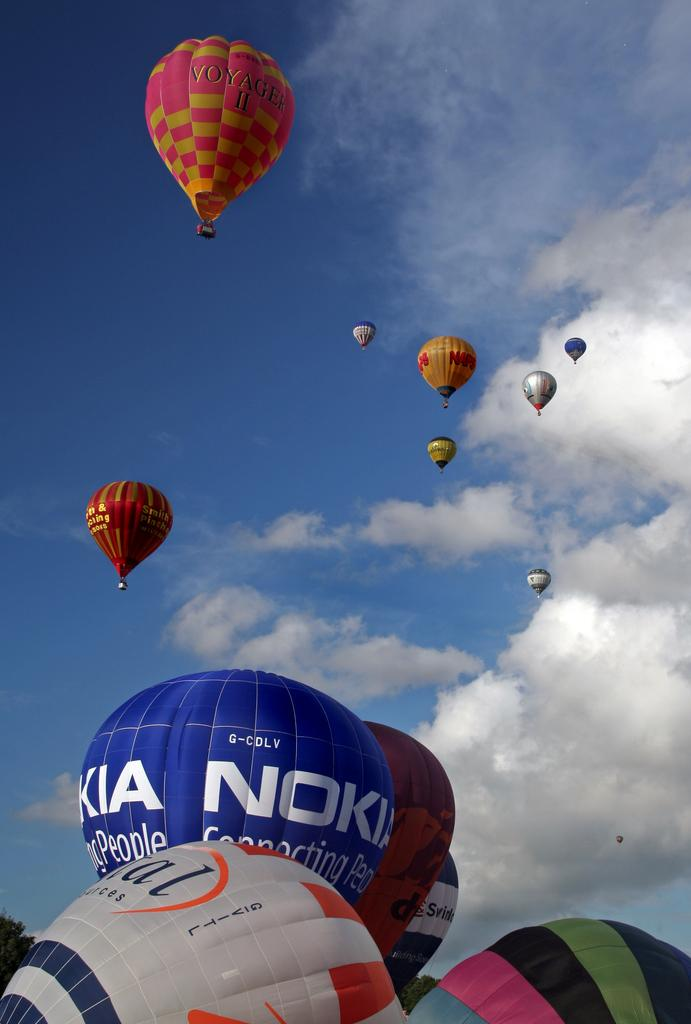<image>
Create a compact narrative representing the image presented. A number of hot air balloons printed with sponsors from companies such as Nokia taking to the sky. 